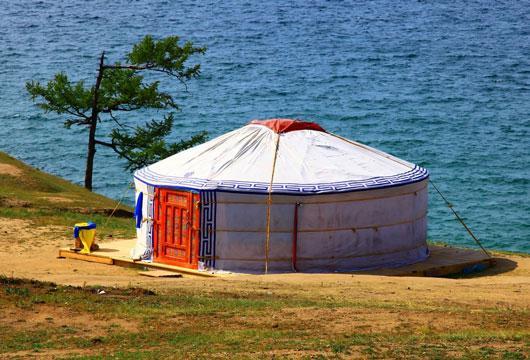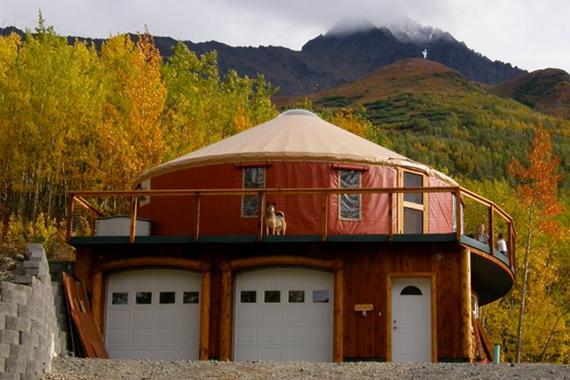The first image is the image on the left, the second image is the image on the right. Analyze the images presented: Is the assertion "At least one image you can see inside of the house." valid? Answer yes or no. No. 